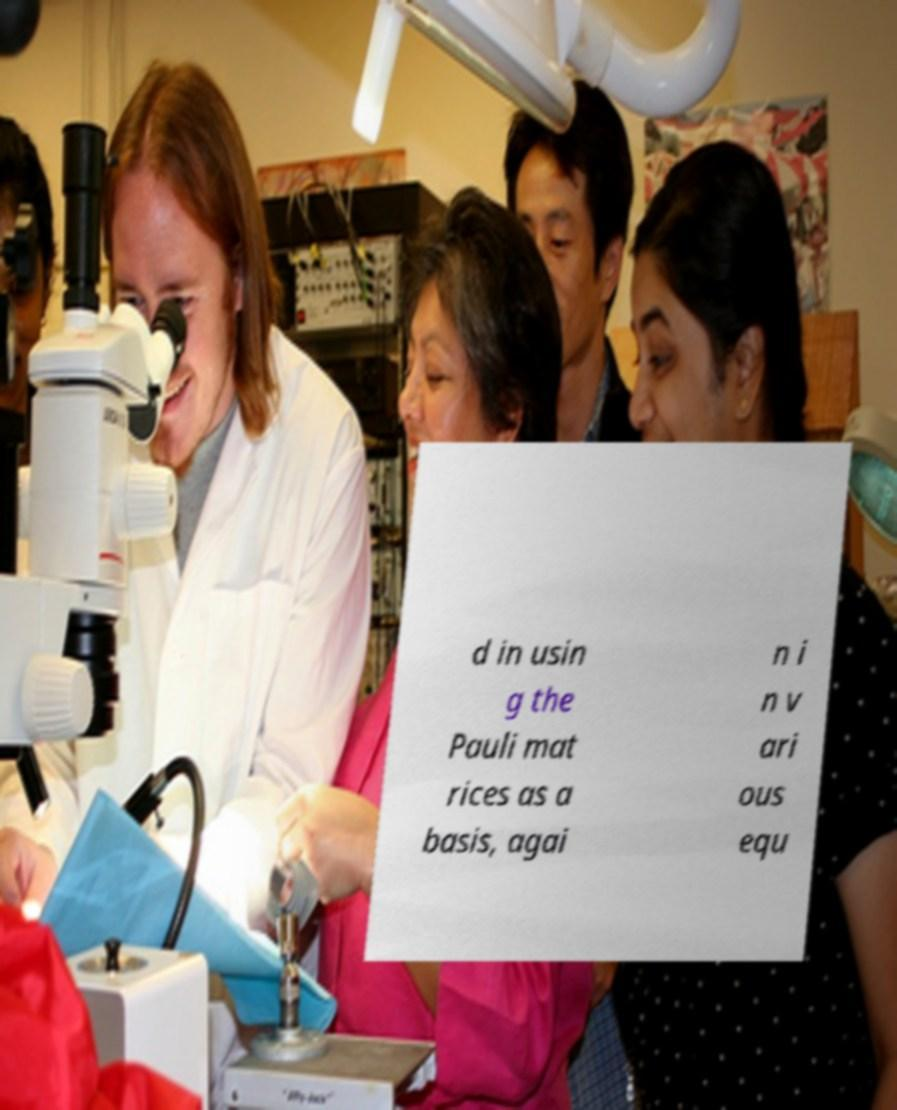What messages or text are displayed in this image? I need them in a readable, typed format. d in usin g the Pauli mat rices as a basis, agai n i n v ari ous equ 